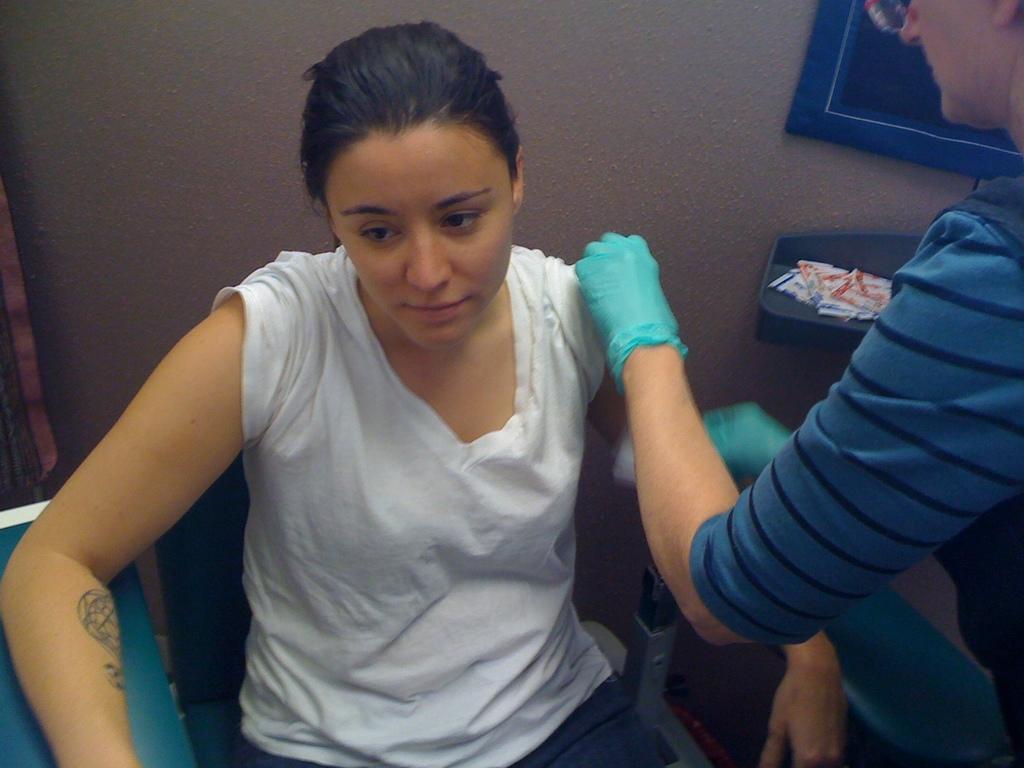Can you describe this image briefly? In this picture there is a woman sitting on the chair and there is a person standing. At the back there are objects and there is a wall. 